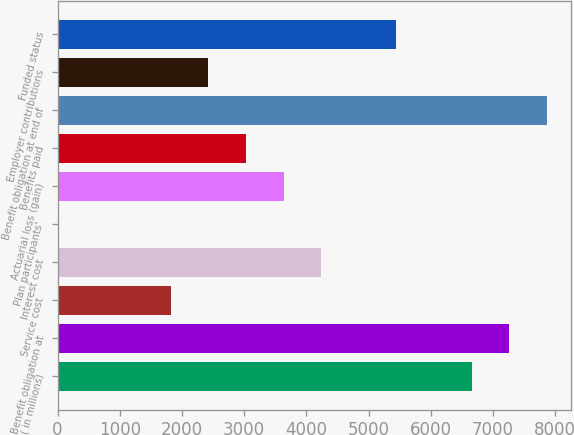Convert chart. <chart><loc_0><loc_0><loc_500><loc_500><bar_chart><fcel>( in millions)<fcel>Benefit obligation at<fcel>Service cost<fcel>Interest cost<fcel>Plan participants'<fcel>Actuarial loss (gain)<fcel>Benefits paid<fcel>Benefit obligation at end of<fcel>Employer contributions<fcel>Funded status<nl><fcel>6654.2<fcel>7258.4<fcel>1820.6<fcel>4237.4<fcel>8<fcel>3633.2<fcel>3029<fcel>7862.6<fcel>2424.8<fcel>5445.8<nl></chart> 